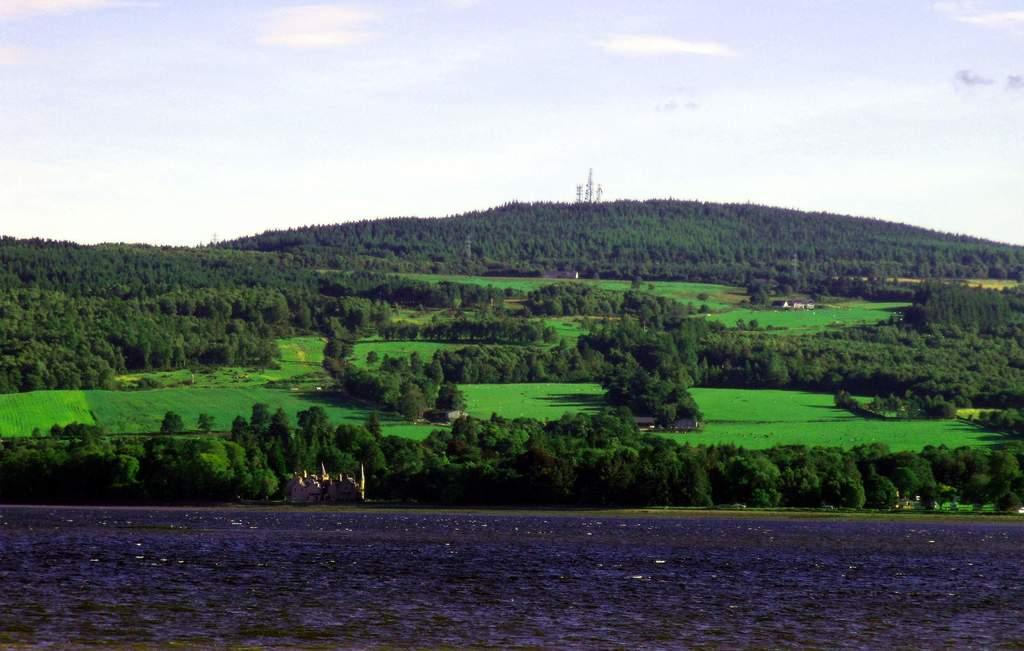What type of vegetation can be seen in the image? There are trees, plants, and grass visible in the image. What type of structure is present in the image? There is a house, towers, and a castle in the image. What natural element is visible in the image? There is water visible in the image. What is visible in the background of the image? There is sky, clouds, and possibly more vegetation visible in the background of the image. What type of apparel is being worn by the range in the image? There is no range or apparel present in the image. How does the hot weather affect the plants in the image? The image does not provide information about the weather, so we cannot determine if it is hot or how it affects the plants. 